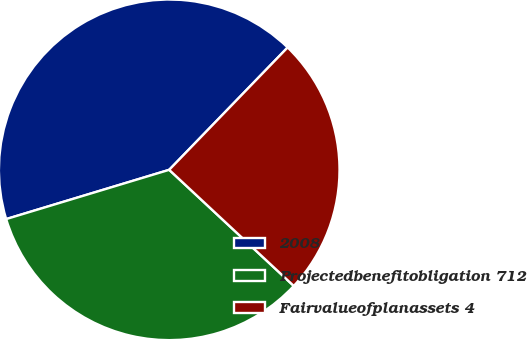<chart> <loc_0><loc_0><loc_500><loc_500><pie_chart><fcel>2008<fcel>Projectedbenefitobligation 712<fcel>Fairvalueofplanassets 4<nl><fcel>41.91%<fcel>33.39%<fcel>24.7%<nl></chart> 